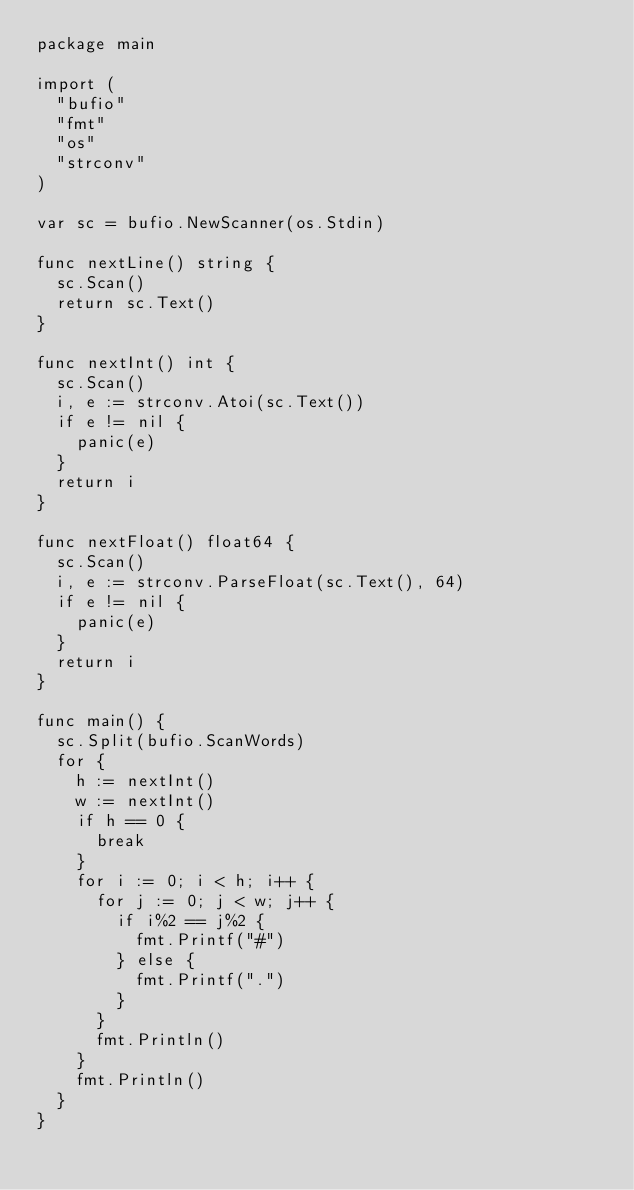Convert code to text. <code><loc_0><loc_0><loc_500><loc_500><_Go_>package main

import (
	"bufio"
	"fmt"
	"os"
	"strconv"
)

var sc = bufio.NewScanner(os.Stdin)

func nextLine() string {
	sc.Scan()
	return sc.Text()
}

func nextInt() int {
	sc.Scan()
	i, e := strconv.Atoi(sc.Text())
	if e != nil {
		panic(e)
	}
	return i
}

func nextFloat() float64 {
	sc.Scan()
	i, e := strconv.ParseFloat(sc.Text(), 64)
	if e != nil {
		panic(e)
	}
	return i
}

func main() {
	sc.Split(bufio.ScanWords)
	for {
		h := nextInt()
		w := nextInt()
		if h == 0 {
			break
		}
		for i := 0; i < h; i++ {
			for j := 0; j < w; j++ {
				if i%2 == j%2 {
					fmt.Printf("#")
				} else {
					fmt.Printf(".")
				}
			}
			fmt.Println()
		}
		fmt.Println()
	}
}

</code> 